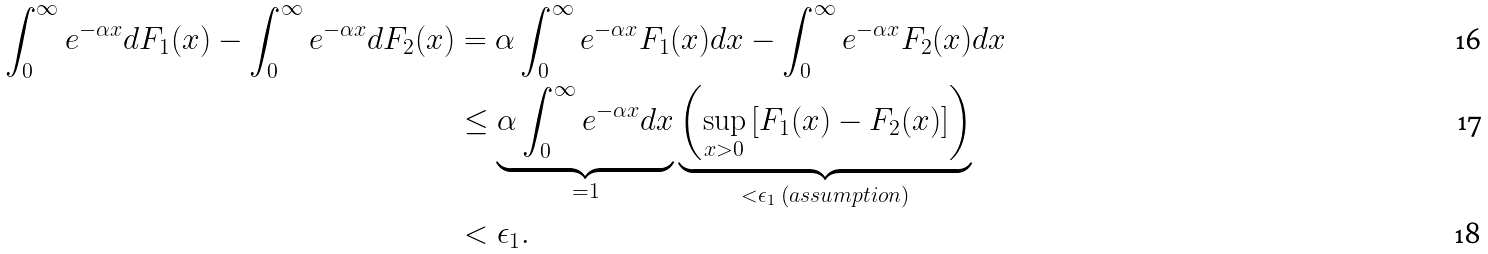Convert formula to latex. <formula><loc_0><loc_0><loc_500><loc_500>\int _ { 0 } ^ { \infty } e ^ { - \alpha x } d F _ { 1 } ( x ) - \int _ { 0 } ^ { \infty } e ^ { - \alpha x } d F _ { 2 } ( x ) & = \alpha \int _ { 0 } ^ { \infty } e ^ { - \alpha x } F _ { 1 } ( x ) d x - \int _ { 0 } ^ { \infty } e ^ { - \alpha x } F _ { 2 } ( x ) d x \\ & \leq \underbrace { \alpha \int _ { 0 } ^ { \infty } e ^ { - \alpha x } d x } _ { = 1 } \underbrace { \left ( \sup _ { x > 0 } \left [ F _ { 1 } ( x ) - F _ { 2 } ( x ) \right ] \right ) } _ { < \epsilon _ { 1 } \ ( a s s u m p t i o n ) } \\ & < \epsilon _ { 1 } .</formula> 